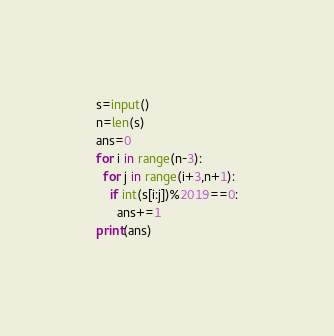<code> <loc_0><loc_0><loc_500><loc_500><_Cython_>s=input()
n=len(s)
ans=0
for i in range(n-3):
  for j in range(i+3,n+1):
    if int(s[i:j])%2019==0:
      ans+=1
print(ans)</code> 